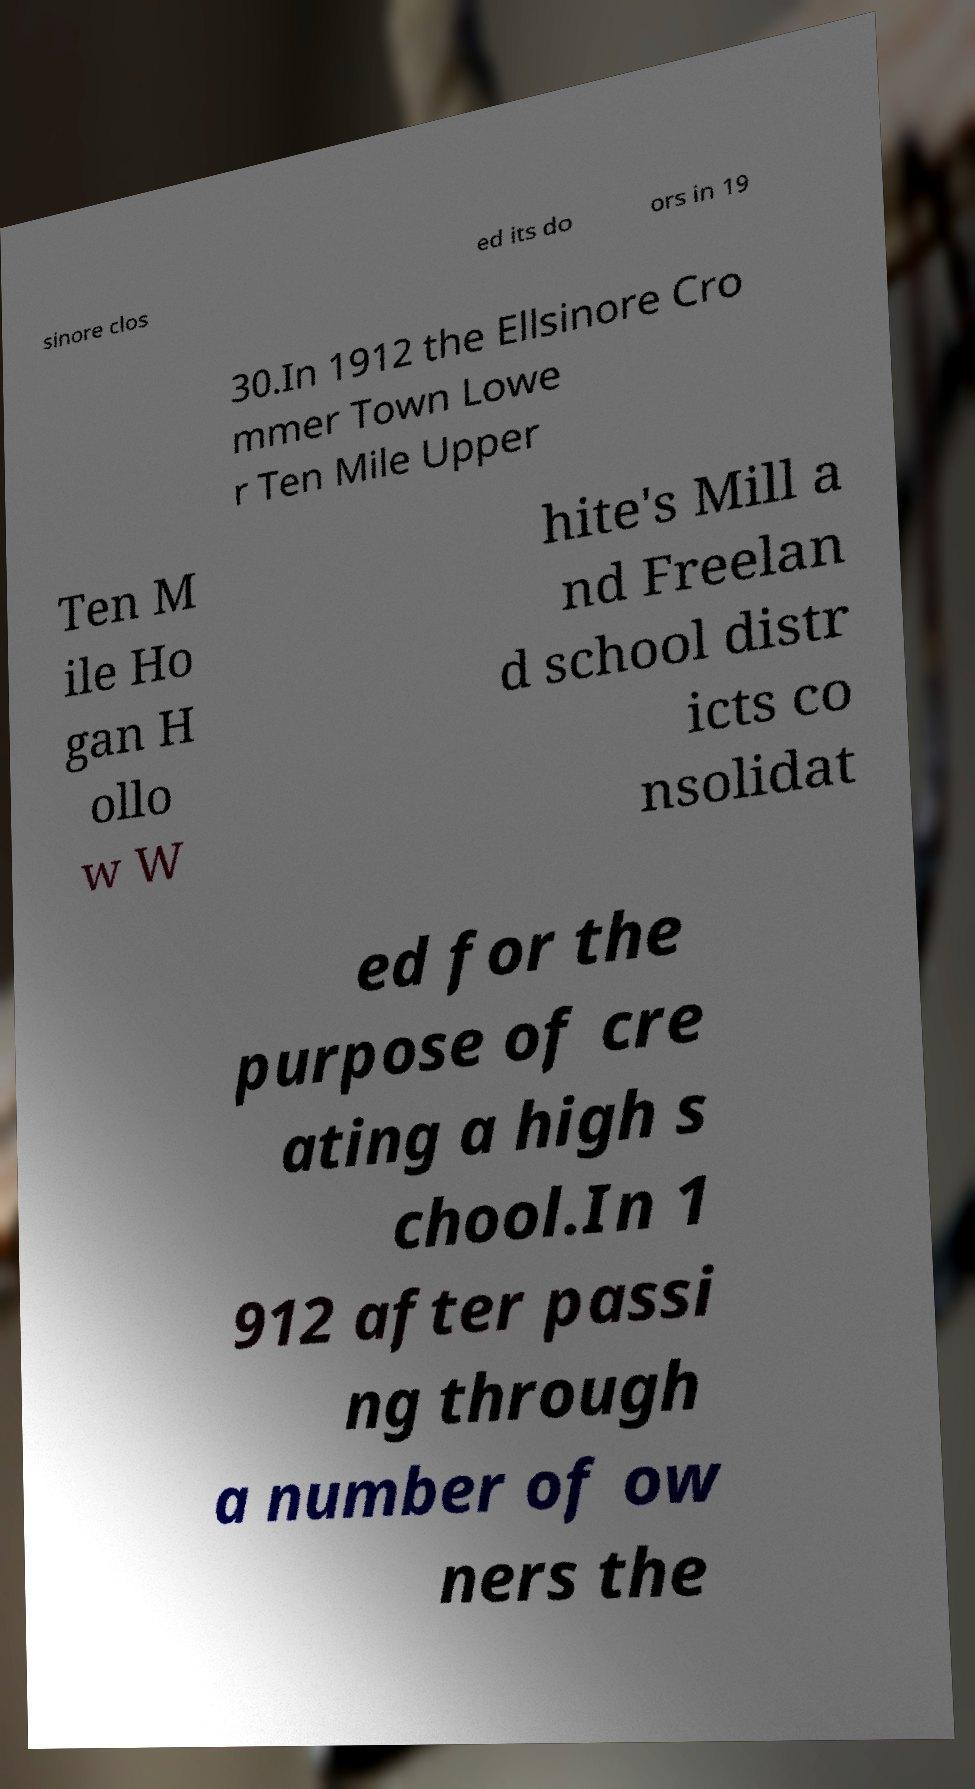Could you assist in decoding the text presented in this image and type it out clearly? sinore clos ed its do ors in 19 30.In 1912 the Ellsinore Cro mmer Town Lowe r Ten Mile Upper Ten M ile Ho gan H ollo w W hite's Mill a nd Freelan d school distr icts co nsolidat ed for the purpose of cre ating a high s chool.In 1 912 after passi ng through a number of ow ners the 